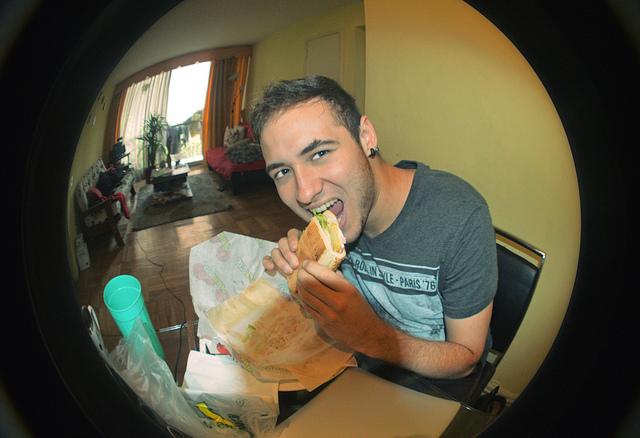Is this man taking careful bites?
Short answer required. Yes. Are the man's eyes closed?
Be succinct. No. What is the color of the stripe?
Be succinct. White. What kind of sandwiches?
Be succinct. Chicken. 